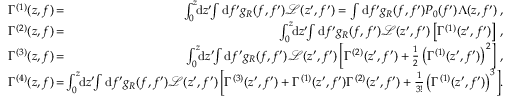Convert formula to latex. <formula><loc_0><loc_0><loc_500><loc_500>\begin{array} { r l r } { \Gamma ^ { ( 1 ) } ( z , f ) \, } & { = } & { \, \int _ { 0 } ^ { z } \, d z ^ { \prime } \, \int d f ^ { \prime } g _ { R } ( f , f ^ { \prime } ) \mathcal { L } ( z ^ { \prime } , f ^ { \prime } ) = \int d f ^ { \prime } g _ { R } ( f , f ^ { \prime } ) P _ { 0 } ( f ^ { \prime } ) \Lambda ( z , f ^ { \prime } ) \, , } \\ { \Gamma ^ { ( 2 ) } ( z , f ) \, } & { = } & { \, \int _ { 0 } ^ { z } \, d z ^ { \prime } \, \int d f ^ { \prime } g _ { R } ( f , f ^ { \prime } ) \mathcal { L } ( z ^ { \prime } , f ^ { \prime } ) \left [ \Gamma ^ { ( 1 ) } ( z ^ { \prime } , f ^ { \prime } ) \right ] \, , } \\ { \Gamma ^ { ( 3 ) } ( z , f ) \, } & { = } & { \, \int _ { 0 } ^ { z } \, d z ^ { \prime } \, \int d f ^ { \prime } g _ { R } ( f , f ^ { \prime } ) \mathcal { L } ( z ^ { \prime } , f ^ { \prime } ) \left [ \Gamma ^ { ( 2 ) } ( z ^ { \prime } , f ^ { \prime } ) + \frac { 1 } { 2 } \left ( \Gamma ^ { ( 1 ) } ( z ^ { \prime } , f ^ { \prime } ) \right ) ^ { 2 } \right ] \, , } \\ { \Gamma ^ { ( 4 ) } ( z , f ) \, } & { = } & { \, \int _ { 0 } ^ { z } \, d z ^ { \prime } \, \int d f ^ { \prime } g _ { R } ( f , f ^ { \prime } ) \mathcal { L } ( z ^ { \prime } , f ^ { \prime } ) \left [ \Gamma ^ { ( 3 ) } ( z ^ { \prime } , f ^ { \prime } ) + \Gamma ^ { ( 1 ) } ( z ^ { \prime } , f ^ { \prime } ) \Gamma ^ { ( 2 ) } ( z ^ { \prime } , f ^ { \prime } ) + \frac { 1 } { 3 ! } \left ( \Gamma ^ { ( 1 ) } ( z ^ { \prime } , f ^ { \prime } ) \right ) ^ { 3 } \right ] \, . } \end{array}</formula> 